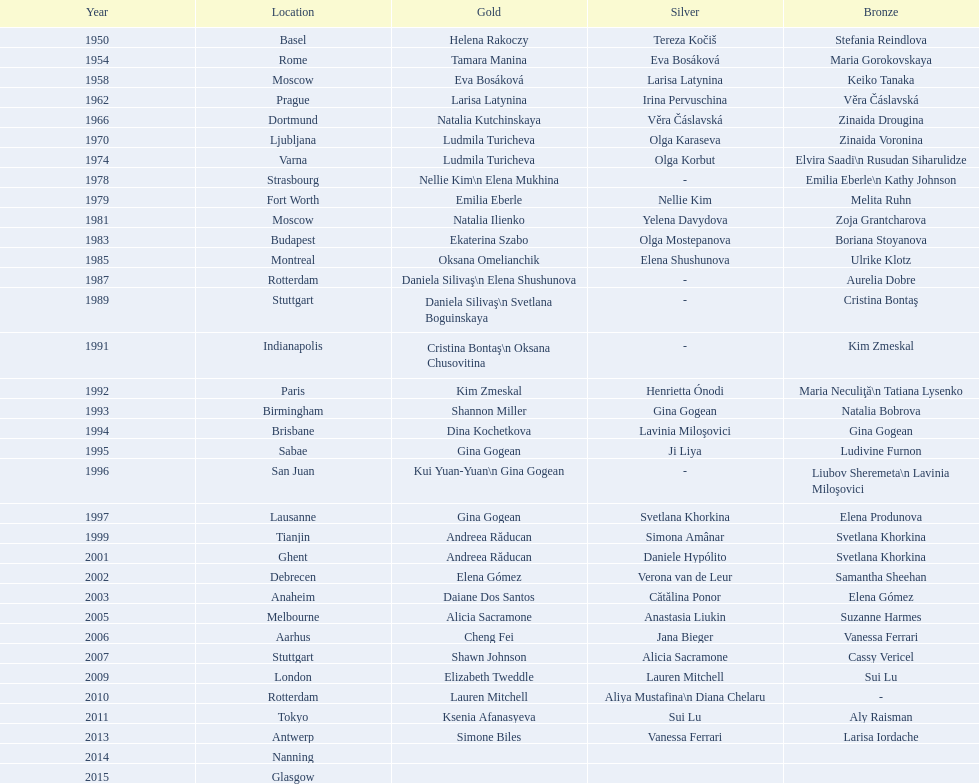In 1992 and 1993, which two american opponents successively claimed the gold medals for floor exercise at the artistic gymnastics world championships? Kim Zmeskal, Shannon Miller. 